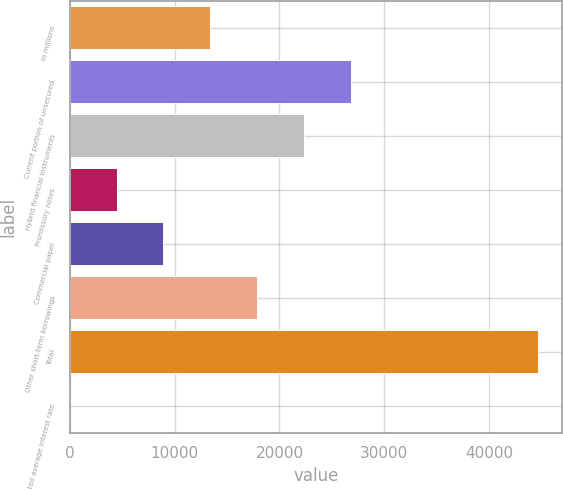Convert chart. <chart><loc_0><loc_0><loc_500><loc_500><bar_chart><fcel>in millions<fcel>Current portion of unsecured<fcel>Hybrid financial instruments<fcel>Promissory notes<fcel>Commercial paper<fcel>Other short-term borrowings<fcel>Total<fcel>Weighted average interest rate<nl><fcel>13408.8<fcel>26815.8<fcel>22346.8<fcel>4470.68<fcel>8939.72<fcel>17877.8<fcel>44692<fcel>1.65<nl></chart> 